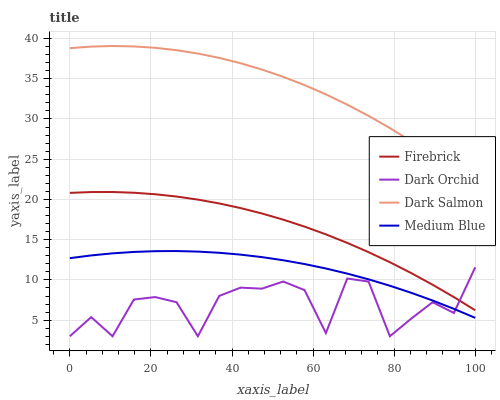Does Medium Blue have the minimum area under the curve?
Answer yes or no. No. Does Medium Blue have the maximum area under the curve?
Answer yes or no. No. Is Dark Salmon the smoothest?
Answer yes or no. No. Is Dark Salmon the roughest?
Answer yes or no. No. Does Medium Blue have the lowest value?
Answer yes or no. No. Does Medium Blue have the highest value?
Answer yes or no. No. Is Firebrick less than Dark Salmon?
Answer yes or no. Yes. Is Dark Salmon greater than Dark Orchid?
Answer yes or no. Yes. Does Firebrick intersect Dark Salmon?
Answer yes or no. No. 